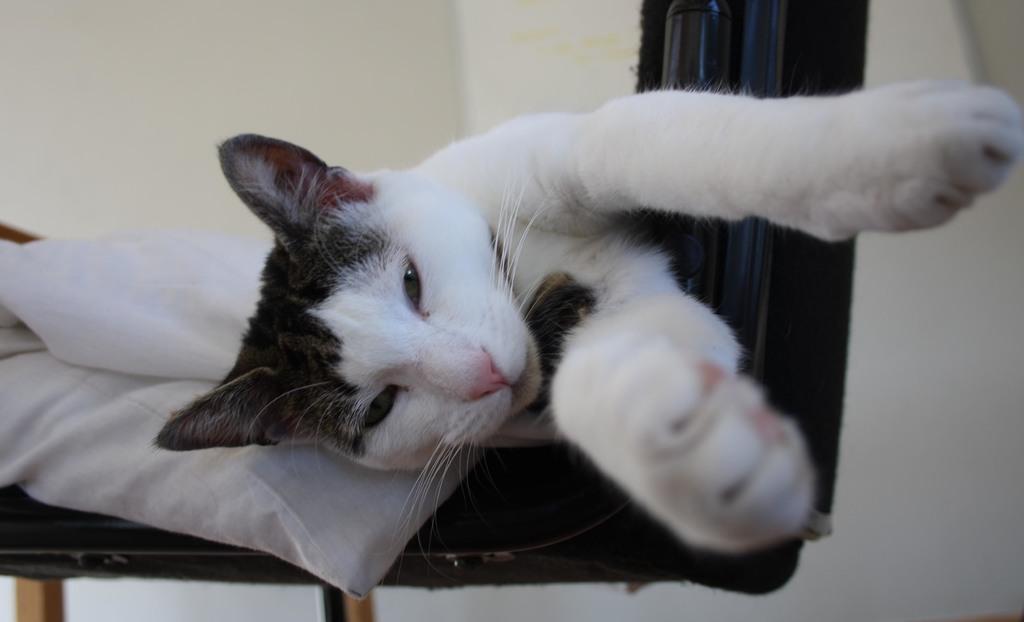Describe this image in one or two sentences. In this image there is a black color chair and there is a cat on the pillow which is placed on the chair. In the background there is plain wall. 